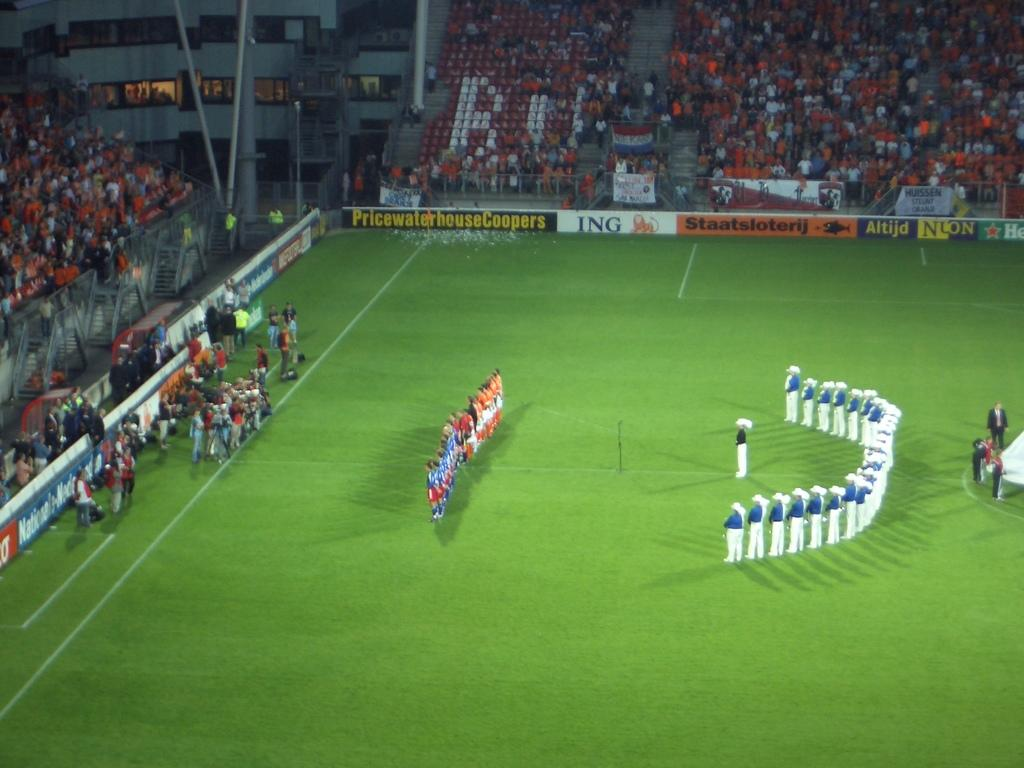<image>
Relay a brief, clear account of the picture shown. A group of people stand on the field of a stadium of which ING is one of the sponsors. 